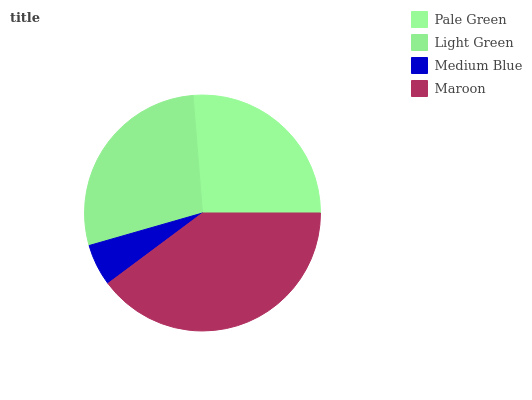Is Medium Blue the minimum?
Answer yes or no. Yes. Is Maroon the maximum?
Answer yes or no. Yes. Is Light Green the minimum?
Answer yes or no. No. Is Light Green the maximum?
Answer yes or no. No. Is Light Green greater than Pale Green?
Answer yes or no. Yes. Is Pale Green less than Light Green?
Answer yes or no. Yes. Is Pale Green greater than Light Green?
Answer yes or no. No. Is Light Green less than Pale Green?
Answer yes or no. No. Is Light Green the high median?
Answer yes or no. Yes. Is Pale Green the low median?
Answer yes or no. Yes. Is Medium Blue the high median?
Answer yes or no. No. Is Maroon the low median?
Answer yes or no. No. 